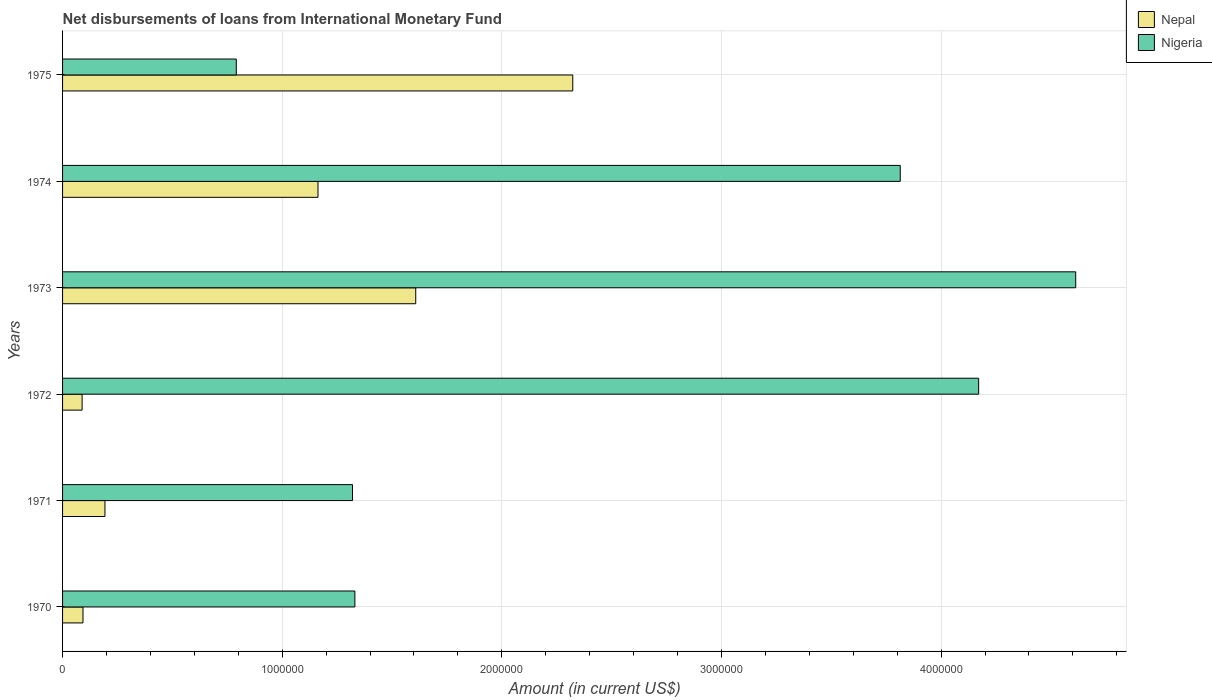How many groups of bars are there?
Provide a short and direct response. 6. How many bars are there on the 5th tick from the top?
Provide a succinct answer. 2. What is the label of the 5th group of bars from the top?
Your response must be concise. 1971. In how many cases, is the number of bars for a given year not equal to the number of legend labels?
Give a very brief answer. 0. What is the amount of loans disbursed in Nepal in 1971?
Keep it short and to the point. 1.93e+05. Across all years, what is the maximum amount of loans disbursed in Nigeria?
Offer a very short reply. 4.61e+06. Across all years, what is the minimum amount of loans disbursed in Nepal?
Your answer should be compact. 8.90e+04. In which year was the amount of loans disbursed in Nepal maximum?
Keep it short and to the point. 1975. What is the total amount of loans disbursed in Nepal in the graph?
Provide a succinct answer. 5.47e+06. What is the difference between the amount of loans disbursed in Nigeria in 1970 and that in 1973?
Offer a terse response. -3.28e+06. What is the difference between the amount of loans disbursed in Nepal in 1970 and the amount of loans disbursed in Nigeria in 1975?
Your response must be concise. -6.98e+05. What is the average amount of loans disbursed in Nigeria per year?
Offer a very short reply. 2.67e+06. In the year 1973, what is the difference between the amount of loans disbursed in Nepal and amount of loans disbursed in Nigeria?
Give a very brief answer. -3.00e+06. What is the ratio of the amount of loans disbursed in Nepal in 1970 to that in 1973?
Give a very brief answer. 0.06. What is the difference between the highest and the second highest amount of loans disbursed in Nepal?
Give a very brief answer. 7.15e+05. What is the difference between the highest and the lowest amount of loans disbursed in Nigeria?
Provide a short and direct response. 3.82e+06. In how many years, is the amount of loans disbursed in Nigeria greater than the average amount of loans disbursed in Nigeria taken over all years?
Ensure brevity in your answer.  3. What does the 1st bar from the top in 1972 represents?
Give a very brief answer. Nigeria. What does the 2nd bar from the bottom in 1975 represents?
Give a very brief answer. Nigeria. How many bars are there?
Provide a short and direct response. 12. Are all the bars in the graph horizontal?
Give a very brief answer. Yes. How many years are there in the graph?
Your answer should be compact. 6. Does the graph contain grids?
Your answer should be compact. Yes. How many legend labels are there?
Offer a very short reply. 2. How are the legend labels stacked?
Give a very brief answer. Vertical. What is the title of the graph?
Ensure brevity in your answer.  Net disbursements of loans from International Monetary Fund. Does "Armenia" appear as one of the legend labels in the graph?
Make the answer very short. No. What is the label or title of the Y-axis?
Ensure brevity in your answer.  Years. What is the Amount (in current US$) in Nepal in 1970?
Provide a short and direct response. 9.30e+04. What is the Amount (in current US$) of Nigeria in 1970?
Provide a succinct answer. 1.33e+06. What is the Amount (in current US$) of Nepal in 1971?
Give a very brief answer. 1.93e+05. What is the Amount (in current US$) in Nigeria in 1971?
Provide a short and direct response. 1.32e+06. What is the Amount (in current US$) of Nepal in 1972?
Offer a terse response. 8.90e+04. What is the Amount (in current US$) in Nigeria in 1972?
Make the answer very short. 4.17e+06. What is the Amount (in current US$) of Nepal in 1973?
Provide a succinct answer. 1.61e+06. What is the Amount (in current US$) in Nigeria in 1973?
Give a very brief answer. 4.61e+06. What is the Amount (in current US$) in Nepal in 1974?
Your answer should be compact. 1.16e+06. What is the Amount (in current US$) of Nigeria in 1974?
Your response must be concise. 3.81e+06. What is the Amount (in current US$) in Nepal in 1975?
Provide a succinct answer. 2.32e+06. What is the Amount (in current US$) in Nigeria in 1975?
Ensure brevity in your answer.  7.91e+05. Across all years, what is the maximum Amount (in current US$) of Nepal?
Offer a very short reply. 2.32e+06. Across all years, what is the maximum Amount (in current US$) of Nigeria?
Provide a short and direct response. 4.61e+06. Across all years, what is the minimum Amount (in current US$) of Nepal?
Your response must be concise. 8.90e+04. Across all years, what is the minimum Amount (in current US$) in Nigeria?
Make the answer very short. 7.91e+05. What is the total Amount (in current US$) of Nepal in the graph?
Your response must be concise. 5.47e+06. What is the total Amount (in current US$) of Nigeria in the graph?
Your answer should be very brief. 1.60e+07. What is the difference between the Amount (in current US$) of Nepal in 1970 and that in 1971?
Offer a very short reply. -1.00e+05. What is the difference between the Amount (in current US$) in Nigeria in 1970 and that in 1971?
Ensure brevity in your answer.  1.10e+04. What is the difference between the Amount (in current US$) in Nepal in 1970 and that in 1972?
Give a very brief answer. 4000. What is the difference between the Amount (in current US$) in Nigeria in 1970 and that in 1972?
Ensure brevity in your answer.  -2.84e+06. What is the difference between the Amount (in current US$) of Nepal in 1970 and that in 1973?
Offer a very short reply. -1.52e+06. What is the difference between the Amount (in current US$) of Nigeria in 1970 and that in 1973?
Keep it short and to the point. -3.28e+06. What is the difference between the Amount (in current US$) in Nepal in 1970 and that in 1974?
Offer a very short reply. -1.07e+06. What is the difference between the Amount (in current US$) of Nigeria in 1970 and that in 1974?
Keep it short and to the point. -2.48e+06. What is the difference between the Amount (in current US$) of Nepal in 1970 and that in 1975?
Offer a very short reply. -2.23e+06. What is the difference between the Amount (in current US$) in Nigeria in 1970 and that in 1975?
Your answer should be compact. 5.40e+05. What is the difference between the Amount (in current US$) in Nepal in 1971 and that in 1972?
Ensure brevity in your answer.  1.04e+05. What is the difference between the Amount (in current US$) in Nigeria in 1971 and that in 1972?
Provide a short and direct response. -2.85e+06. What is the difference between the Amount (in current US$) of Nepal in 1971 and that in 1973?
Your response must be concise. -1.42e+06. What is the difference between the Amount (in current US$) of Nigeria in 1971 and that in 1973?
Make the answer very short. -3.29e+06. What is the difference between the Amount (in current US$) of Nepal in 1971 and that in 1974?
Make the answer very short. -9.70e+05. What is the difference between the Amount (in current US$) in Nigeria in 1971 and that in 1974?
Your answer should be very brief. -2.49e+06. What is the difference between the Amount (in current US$) in Nepal in 1971 and that in 1975?
Your answer should be compact. -2.13e+06. What is the difference between the Amount (in current US$) of Nigeria in 1971 and that in 1975?
Your answer should be compact. 5.29e+05. What is the difference between the Amount (in current US$) in Nepal in 1972 and that in 1973?
Your answer should be very brief. -1.52e+06. What is the difference between the Amount (in current US$) in Nigeria in 1972 and that in 1973?
Your answer should be compact. -4.42e+05. What is the difference between the Amount (in current US$) of Nepal in 1972 and that in 1974?
Your answer should be very brief. -1.07e+06. What is the difference between the Amount (in current US$) of Nigeria in 1972 and that in 1974?
Keep it short and to the point. 3.57e+05. What is the difference between the Amount (in current US$) of Nepal in 1972 and that in 1975?
Make the answer very short. -2.23e+06. What is the difference between the Amount (in current US$) of Nigeria in 1972 and that in 1975?
Your answer should be very brief. 3.38e+06. What is the difference between the Amount (in current US$) in Nepal in 1973 and that in 1974?
Offer a terse response. 4.45e+05. What is the difference between the Amount (in current US$) in Nigeria in 1973 and that in 1974?
Provide a succinct answer. 7.99e+05. What is the difference between the Amount (in current US$) of Nepal in 1973 and that in 1975?
Your answer should be very brief. -7.15e+05. What is the difference between the Amount (in current US$) in Nigeria in 1973 and that in 1975?
Ensure brevity in your answer.  3.82e+06. What is the difference between the Amount (in current US$) in Nepal in 1974 and that in 1975?
Your answer should be very brief. -1.16e+06. What is the difference between the Amount (in current US$) of Nigeria in 1974 and that in 1975?
Keep it short and to the point. 3.02e+06. What is the difference between the Amount (in current US$) of Nepal in 1970 and the Amount (in current US$) of Nigeria in 1971?
Your answer should be compact. -1.23e+06. What is the difference between the Amount (in current US$) in Nepal in 1970 and the Amount (in current US$) in Nigeria in 1972?
Give a very brief answer. -4.08e+06. What is the difference between the Amount (in current US$) of Nepal in 1970 and the Amount (in current US$) of Nigeria in 1973?
Offer a very short reply. -4.52e+06. What is the difference between the Amount (in current US$) in Nepal in 1970 and the Amount (in current US$) in Nigeria in 1974?
Offer a terse response. -3.72e+06. What is the difference between the Amount (in current US$) in Nepal in 1970 and the Amount (in current US$) in Nigeria in 1975?
Ensure brevity in your answer.  -6.98e+05. What is the difference between the Amount (in current US$) of Nepal in 1971 and the Amount (in current US$) of Nigeria in 1972?
Your answer should be very brief. -3.98e+06. What is the difference between the Amount (in current US$) of Nepal in 1971 and the Amount (in current US$) of Nigeria in 1973?
Ensure brevity in your answer.  -4.42e+06. What is the difference between the Amount (in current US$) in Nepal in 1971 and the Amount (in current US$) in Nigeria in 1974?
Your answer should be compact. -3.62e+06. What is the difference between the Amount (in current US$) of Nepal in 1971 and the Amount (in current US$) of Nigeria in 1975?
Make the answer very short. -5.98e+05. What is the difference between the Amount (in current US$) of Nepal in 1972 and the Amount (in current US$) of Nigeria in 1973?
Keep it short and to the point. -4.52e+06. What is the difference between the Amount (in current US$) of Nepal in 1972 and the Amount (in current US$) of Nigeria in 1974?
Ensure brevity in your answer.  -3.72e+06. What is the difference between the Amount (in current US$) of Nepal in 1972 and the Amount (in current US$) of Nigeria in 1975?
Provide a short and direct response. -7.02e+05. What is the difference between the Amount (in current US$) in Nepal in 1973 and the Amount (in current US$) in Nigeria in 1974?
Provide a succinct answer. -2.21e+06. What is the difference between the Amount (in current US$) of Nepal in 1973 and the Amount (in current US$) of Nigeria in 1975?
Offer a terse response. 8.17e+05. What is the difference between the Amount (in current US$) in Nepal in 1974 and the Amount (in current US$) in Nigeria in 1975?
Provide a short and direct response. 3.72e+05. What is the average Amount (in current US$) in Nepal per year?
Ensure brevity in your answer.  9.12e+05. What is the average Amount (in current US$) in Nigeria per year?
Your response must be concise. 2.67e+06. In the year 1970, what is the difference between the Amount (in current US$) of Nepal and Amount (in current US$) of Nigeria?
Offer a very short reply. -1.24e+06. In the year 1971, what is the difference between the Amount (in current US$) in Nepal and Amount (in current US$) in Nigeria?
Your answer should be very brief. -1.13e+06. In the year 1972, what is the difference between the Amount (in current US$) of Nepal and Amount (in current US$) of Nigeria?
Give a very brief answer. -4.08e+06. In the year 1973, what is the difference between the Amount (in current US$) of Nepal and Amount (in current US$) of Nigeria?
Your answer should be very brief. -3.00e+06. In the year 1974, what is the difference between the Amount (in current US$) of Nepal and Amount (in current US$) of Nigeria?
Provide a succinct answer. -2.65e+06. In the year 1975, what is the difference between the Amount (in current US$) in Nepal and Amount (in current US$) in Nigeria?
Your answer should be compact. 1.53e+06. What is the ratio of the Amount (in current US$) of Nepal in 1970 to that in 1971?
Provide a short and direct response. 0.48. What is the ratio of the Amount (in current US$) in Nigeria in 1970 to that in 1971?
Give a very brief answer. 1.01. What is the ratio of the Amount (in current US$) of Nepal in 1970 to that in 1972?
Give a very brief answer. 1.04. What is the ratio of the Amount (in current US$) of Nigeria in 1970 to that in 1972?
Make the answer very short. 0.32. What is the ratio of the Amount (in current US$) in Nepal in 1970 to that in 1973?
Ensure brevity in your answer.  0.06. What is the ratio of the Amount (in current US$) of Nigeria in 1970 to that in 1973?
Ensure brevity in your answer.  0.29. What is the ratio of the Amount (in current US$) in Nepal in 1970 to that in 1974?
Make the answer very short. 0.08. What is the ratio of the Amount (in current US$) of Nigeria in 1970 to that in 1974?
Make the answer very short. 0.35. What is the ratio of the Amount (in current US$) of Nigeria in 1970 to that in 1975?
Your answer should be very brief. 1.68. What is the ratio of the Amount (in current US$) of Nepal in 1971 to that in 1972?
Provide a short and direct response. 2.17. What is the ratio of the Amount (in current US$) in Nigeria in 1971 to that in 1972?
Offer a very short reply. 0.32. What is the ratio of the Amount (in current US$) of Nepal in 1971 to that in 1973?
Provide a short and direct response. 0.12. What is the ratio of the Amount (in current US$) of Nigeria in 1971 to that in 1973?
Your answer should be very brief. 0.29. What is the ratio of the Amount (in current US$) in Nepal in 1971 to that in 1974?
Provide a short and direct response. 0.17. What is the ratio of the Amount (in current US$) in Nigeria in 1971 to that in 1974?
Make the answer very short. 0.35. What is the ratio of the Amount (in current US$) of Nepal in 1971 to that in 1975?
Keep it short and to the point. 0.08. What is the ratio of the Amount (in current US$) of Nigeria in 1971 to that in 1975?
Offer a very short reply. 1.67. What is the ratio of the Amount (in current US$) in Nepal in 1972 to that in 1973?
Your answer should be very brief. 0.06. What is the ratio of the Amount (in current US$) of Nigeria in 1972 to that in 1973?
Your answer should be very brief. 0.9. What is the ratio of the Amount (in current US$) in Nepal in 1972 to that in 1974?
Provide a short and direct response. 0.08. What is the ratio of the Amount (in current US$) in Nigeria in 1972 to that in 1974?
Make the answer very short. 1.09. What is the ratio of the Amount (in current US$) in Nepal in 1972 to that in 1975?
Keep it short and to the point. 0.04. What is the ratio of the Amount (in current US$) of Nigeria in 1972 to that in 1975?
Your answer should be very brief. 5.27. What is the ratio of the Amount (in current US$) in Nepal in 1973 to that in 1974?
Provide a succinct answer. 1.38. What is the ratio of the Amount (in current US$) in Nigeria in 1973 to that in 1974?
Your response must be concise. 1.21. What is the ratio of the Amount (in current US$) in Nepal in 1973 to that in 1975?
Give a very brief answer. 0.69. What is the ratio of the Amount (in current US$) in Nigeria in 1973 to that in 1975?
Ensure brevity in your answer.  5.83. What is the ratio of the Amount (in current US$) in Nepal in 1974 to that in 1975?
Offer a very short reply. 0.5. What is the ratio of the Amount (in current US$) in Nigeria in 1974 to that in 1975?
Provide a succinct answer. 4.82. What is the difference between the highest and the second highest Amount (in current US$) in Nepal?
Ensure brevity in your answer.  7.15e+05. What is the difference between the highest and the second highest Amount (in current US$) in Nigeria?
Offer a very short reply. 4.42e+05. What is the difference between the highest and the lowest Amount (in current US$) in Nepal?
Your response must be concise. 2.23e+06. What is the difference between the highest and the lowest Amount (in current US$) in Nigeria?
Your response must be concise. 3.82e+06. 